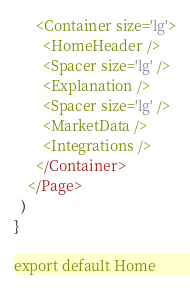Convert code to text. <code><loc_0><loc_0><loc_500><loc_500><_TypeScript_>      <Container size='lg'>
        <HomeHeader />
        <Spacer size='lg' />
        <Explanation />
        <Spacer size='lg' />
        <MarketData />
        <Integrations />
      </Container>
    </Page>
  )
}

export default Home
</code> 